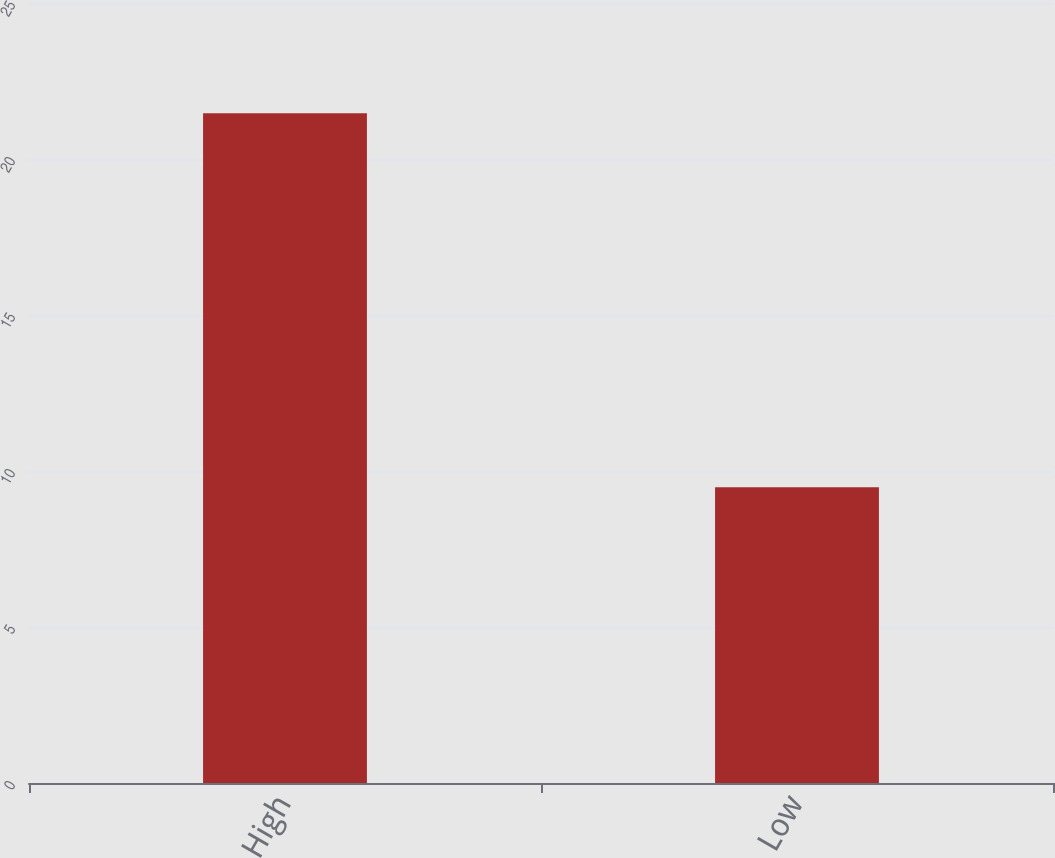Convert chart to OTSL. <chart><loc_0><loc_0><loc_500><loc_500><bar_chart><fcel>High<fcel>Low<nl><fcel>21.47<fcel>9.48<nl></chart> 